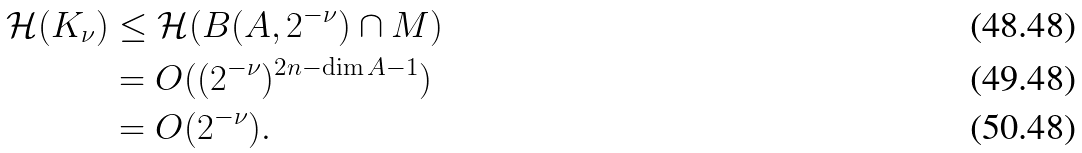<formula> <loc_0><loc_0><loc_500><loc_500>\mathcal { H } ( K _ { \nu } ) & \leq \mathcal { H } ( B ( A , 2 ^ { - \nu } ) \cap M ) \\ & = O ( ( 2 ^ { - \nu } ) ^ { 2 n - \dim A - 1 } ) \\ & = O ( 2 ^ { - \nu } ) .</formula> 